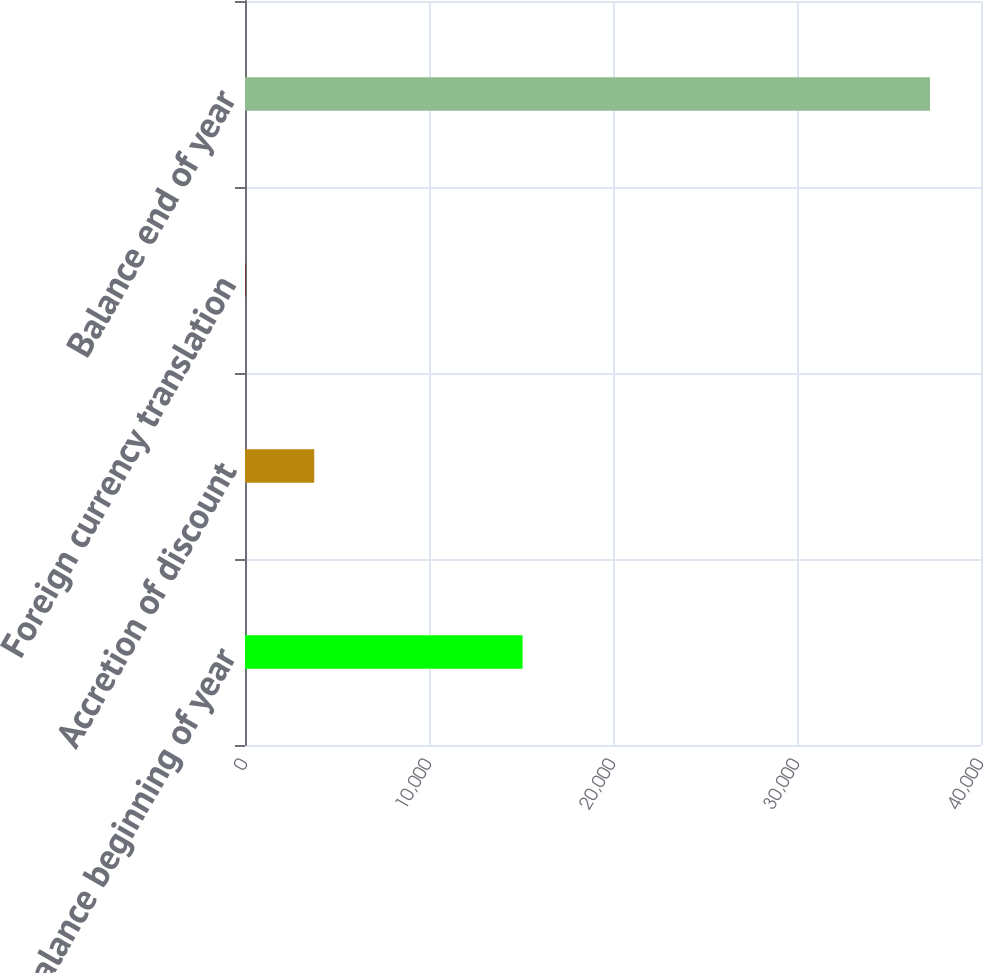<chart> <loc_0><loc_0><loc_500><loc_500><bar_chart><fcel>Balance beginning of year<fcel>Accretion of discount<fcel>Foreign currency translation<fcel>Balance end of year<nl><fcel>15085<fcel>3763.5<fcel>45<fcel>37230<nl></chart> 